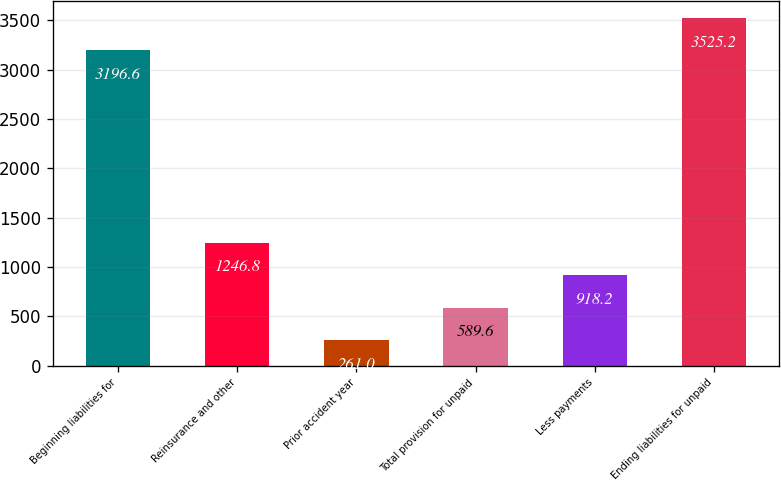Convert chart to OTSL. <chart><loc_0><loc_0><loc_500><loc_500><bar_chart><fcel>Beginning liabilities for<fcel>Reinsurance and other<fcel>Prior accident year<fcel>Total provision for unpaid<fcel>Less payments<fcel>Ending liabilities for unpaid<nl><fcel>3196.6<fcel>1246.8<fcel>261<fcel>589.6<fcel>918.2<fcel>3525.2<nl></chart> 